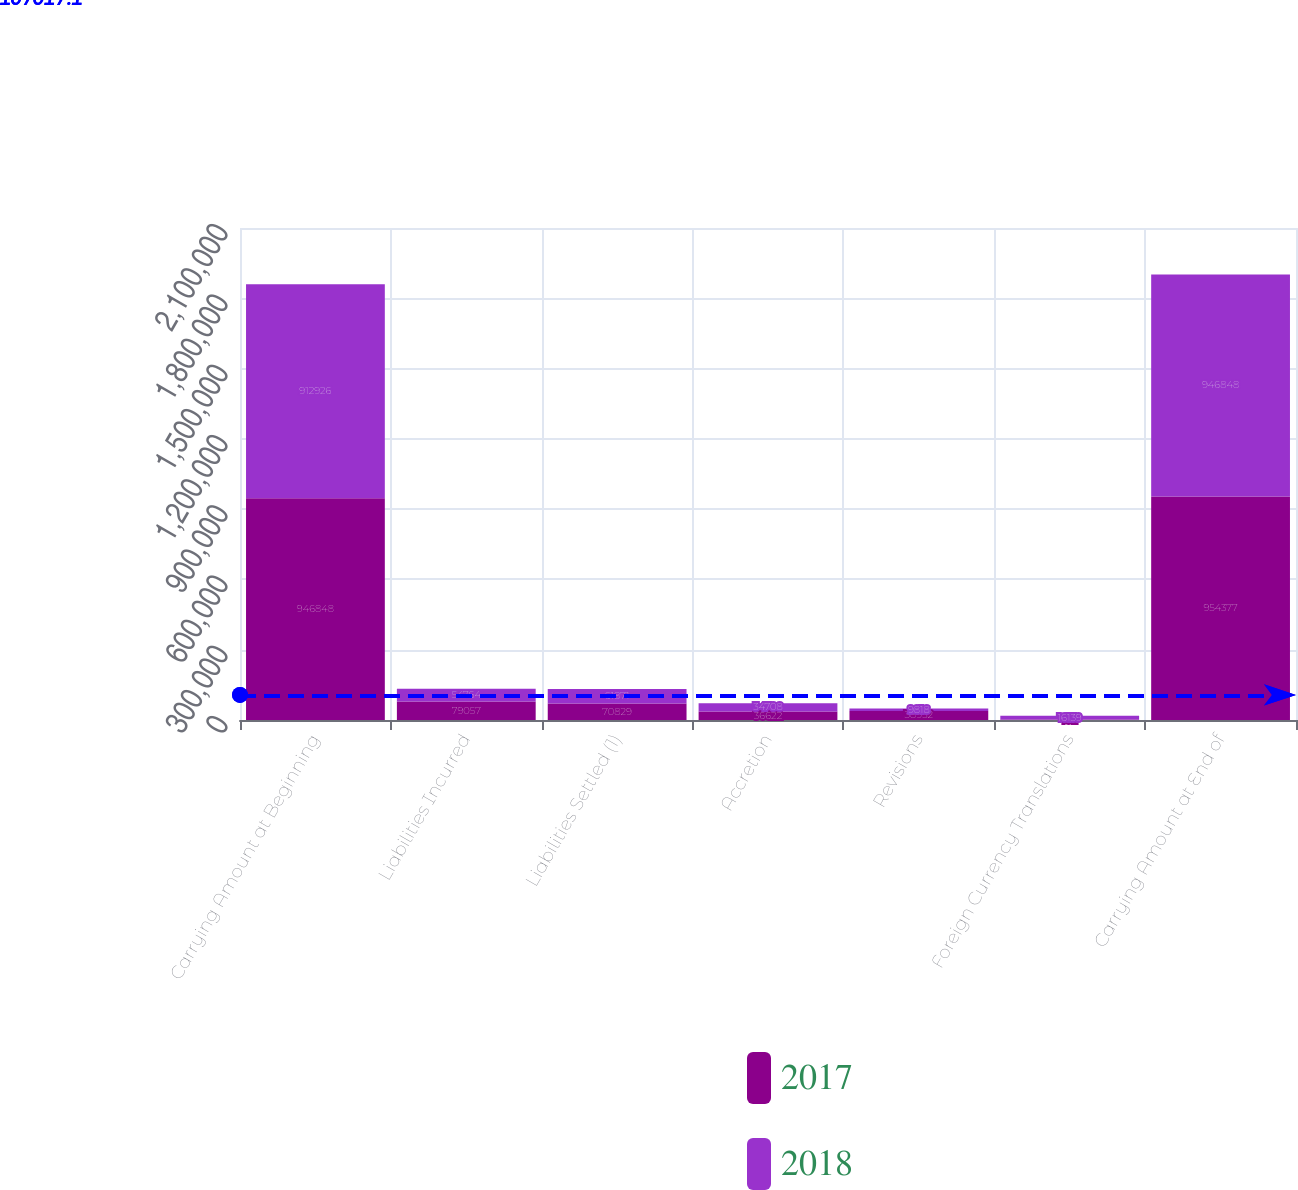<chart> <loc_0><loc_0><loc_500><loc_500><stacked_bar_chart><ecel><fcel>Carrying Amount at Beginning<fcel>Liabilities Incurred<fcel>Liabilities Settled (1)<fcel>Accretion<fcel>Revisions<fcel>Foreign Currency Translations<fcel>Carrying Amount at End of<nl><fcel>2017<fcel>946848<fcel>79057<fcel>70829<fcel>36622<fcel>38932<fcel>1611<fcel>954377<nl><fcel>2018<fcel>912926<fcel>54764<fcel>61871<fcel>34708<fcel>9818<fcel>16139<fcel>946848<nl></chart> 